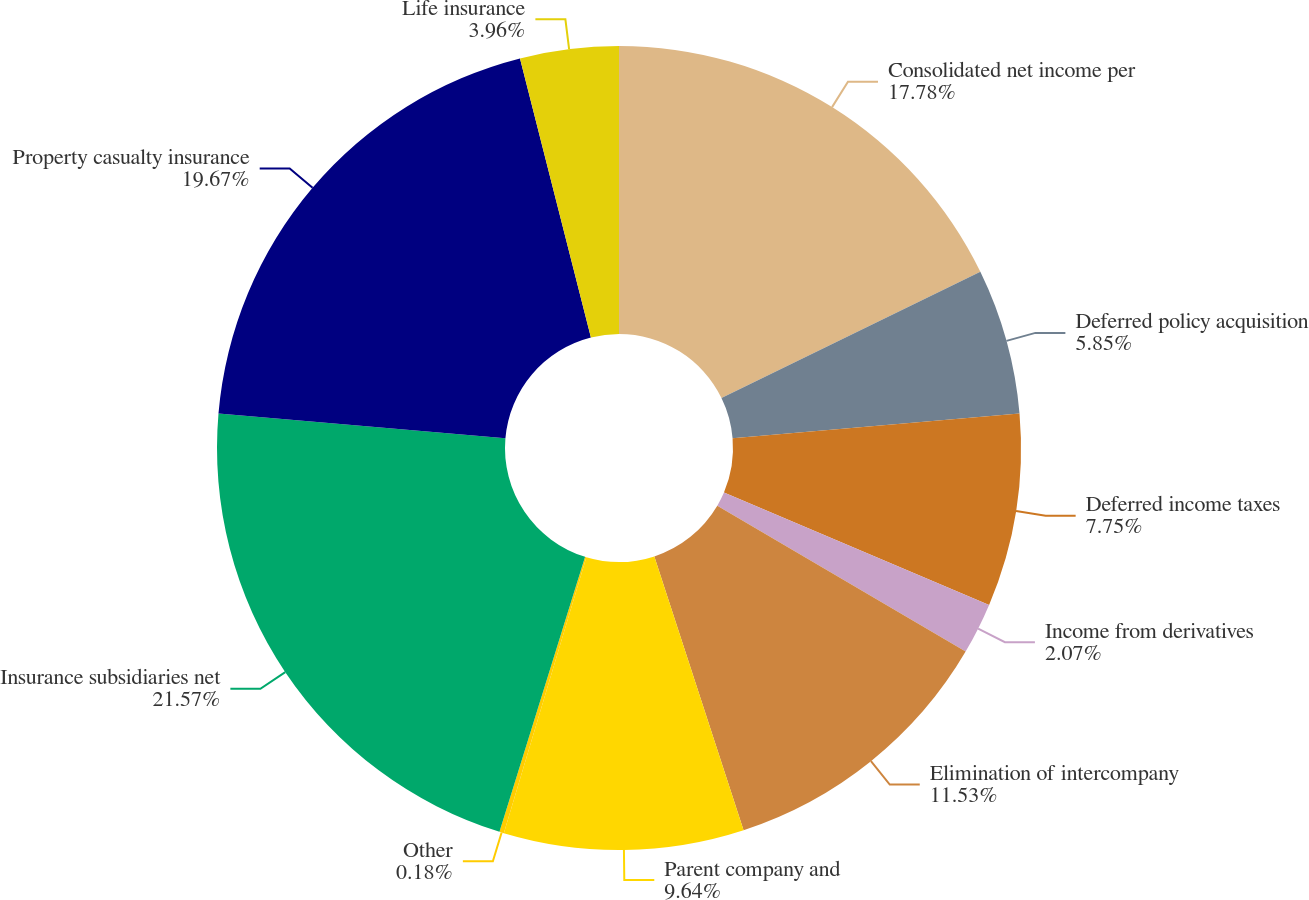Convert chart. <chart><loc_0><loc_0><loc_500><loc_500><pie_chart><fcel>Consolidated net income per<fcel>Deferred policy acquisition<fcel>Deferred income taxes<fcel>Income from derivatives<fcel>Elimination of intercompany<fcel>Parent company and<fcel>Other<fcel>Insurance subsidiaries net<fcel>Property casualty insurance<fcel>Life insurance<nl><fcel>17.78%<fcel>5.85%<fcel>7.75%<fcel>2.07%<fcel>11.53%<fcel>9.64%<fcel>0.18%<fcel>21.56%<fcel>19.67%<fcel>3.96%<nl></chart> 